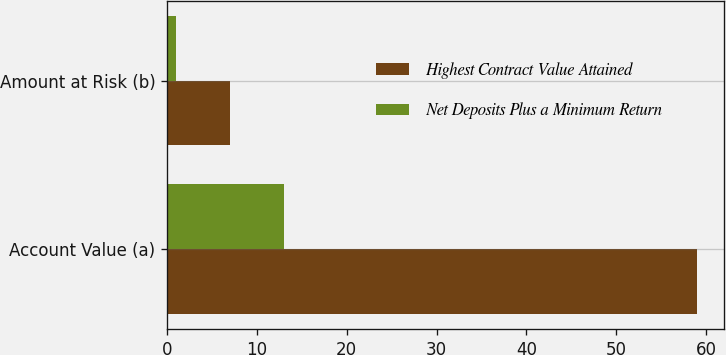Convert chart. <chart><loc_0><loc_0><loc_500><loc_500><stacked_bar_chart><ecel><fcel>Account Value (a)<fcel>Amount at Risk (b)<nl><fcel>Highest Contract Value Attained<fcel>59<fcel>7<nl><fcel>Net Deposits Plus a Minimum Return<fcel>13<fcel>1<nl></chart> 